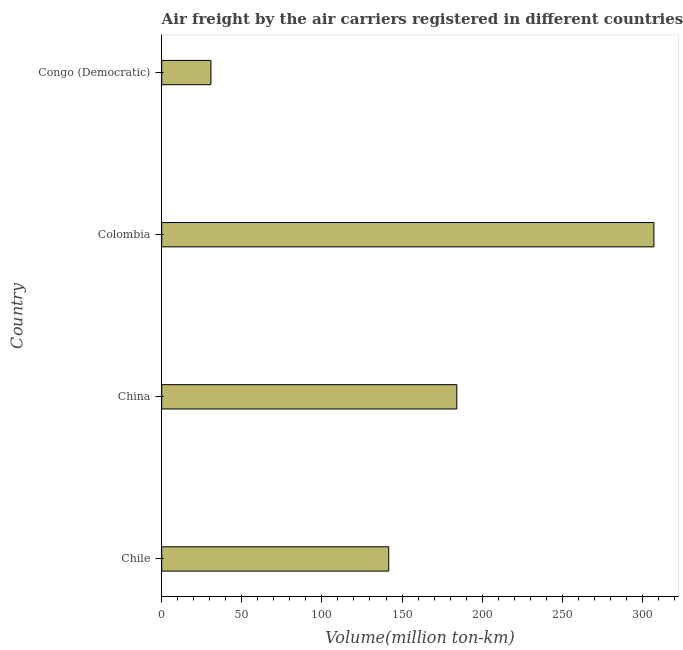Does the graph contain any zero values?
Offer a very short reply. No. Does the graph contain grids?
Give a very brief answer. No. What is the title of the graph?
Your response must be concise. Air freight by the air carriers registered in different countries. What is the label or title of the X-axis?
Provide a succinct answer. Volume(million ton-km). What is the air freight in Colombia?
Keep it short and to the point. 307.2. Across all countries, what is the maximum air freight?
Make the answer very short. 307.2. Across all countries, what is the minimum air freight?
Keep it short and to the point. 30.7. In which country was the air freight minimum?
Your answer should be very brief. Congo (Democratic). What is the sum of the air freight?
Offer a terse response. 663.8. What is the difference between the air freight in Chile and Colombia?
Provide a short and direct response. -165.5. What is the average air freight per country?
Offer a very short reply. 165.95. What is the median air freight?
Your response must be concise. 162.95. In how many countries, is the air freight greater than 230 million ton-km?
Offer a terse response. 1. What is the ratio of the air freight in China to that in Congo (Democratic)?
Make the answer very short. 6. Is the air freight in China less than that in Colombia?
Ensure brevity in your answer.  Yes. What is the difference between the highest and the second highest air freight?
Offer a terse response. 123. What is the difference between the highest and the lowest air freight?
Your response must be concise. 276.5. Are all the bars in the graph horizontal?
Offer a terse response. Yes. How many countries are there in the graph?
Your answer should be compact. 4. What is the Volume(million ton-km) of Chile?
Offer a terse response. 141.7. What is the Volume(million ton-km) in China?
Your answer should be very brief. 184.2. What is the Volume(million ton-km) of Colombia?
Offer a terse response. 307.2. What is the Volume(million ton-km) of Congo (Democratic)?
Keep it short and to the point. 30.7. What is the difference between the Volume(million ton-km) in Chile and China?
Provide a succinct answer. -42.5. What is the difference between the Volume(million ton-km) in Chile and Colombia?
Provide a succinct answer. -165.5. What is the difference between the Volume(million ton-km) in Chile and Congo (Democratic)?
Your response must be concise. 111. What is the difference between the Volume(million ton-km) in China and Colombia?
Ensure brevity in your answer.  -123. What is the difference between the Volume(million ton-km) in China and Congo (Democratic)?
Keep it short and to the point. 153.5. What is the difference between the Volume(million ton-km) in Colombia and Congo (Democratic)?
Give a very brief answer. 276.5. What is the ratio of the Volume(million ton-km) in Chile to that in China?
Your response must be concise. 0.77. What is the ratio of the Volume(million ton-km) in Chile to that in Colombia?
Offer a very short reply. 0.46. What is the ratio of the Volume(million ton-km) in Chile to that in Congo (Democratic)?
Make the answer very short. 4.62. What is the ratio of the Volume(million ton-km) in China to that in Colombia?
Keep it short and to the point. 0.6. What is the ratio of the Volume(million ton-km) in Colombia to that in Congo (Democratic)?
Your response must be concise. 10.01. 